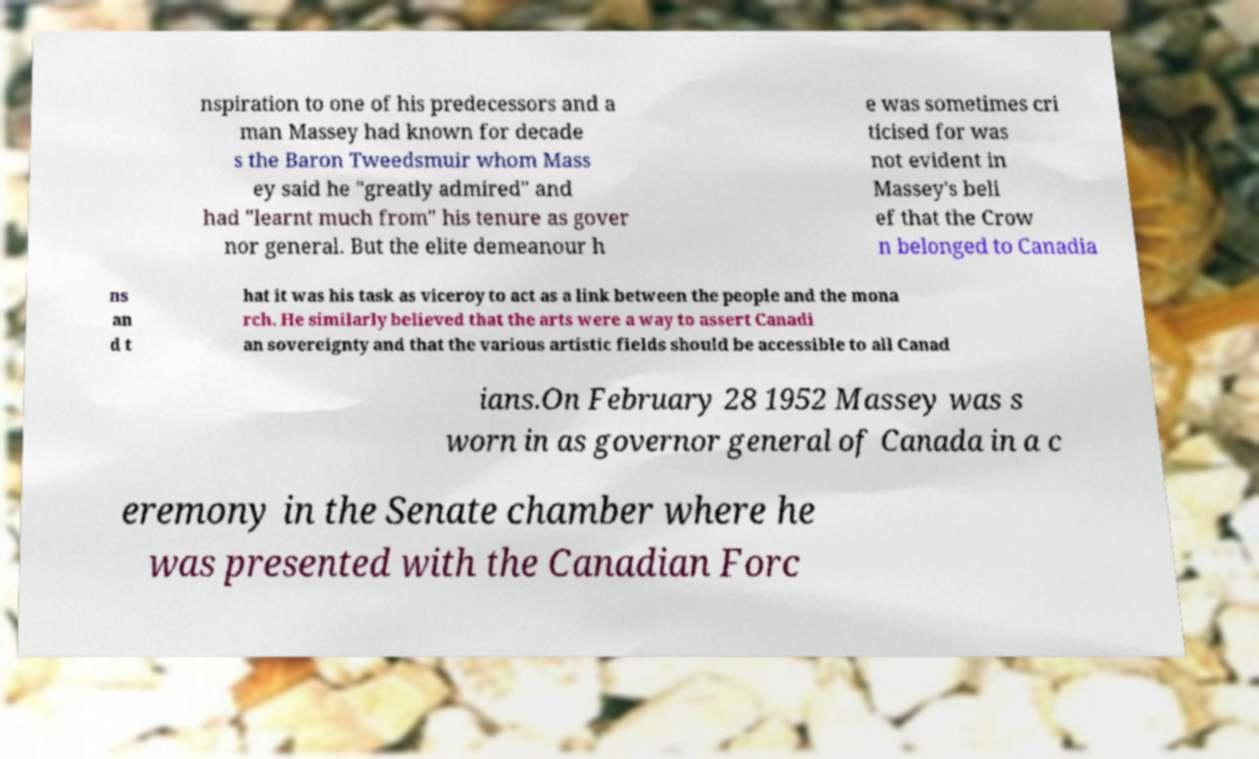For documentation purposes, I need the text within this image transcribed. Could you provide that? nspiration to one of his predecessors and a man Massey had known for decade s the Baron Tweedsmuir whom Mass ey said he "greatly admired" and had "learnt much from" his tenure as gover nor general. But the elite demeanour h e was sometimes cri ticised for was not evident in Massey's beli ef that the Crow n belonged to Canadia ns an d t hat it was his task as viceroy to act as a link between the people and the mona rch. He similarly believed that the arts were a way to assert Canadi an sovereignty and that the various artistic fields should be accessible to all Canad ians.On February 28 1952 Massey was s worn in as governor general of Canada in a c eremony in the Senate chamber where he was presented with the Canadian Forc 